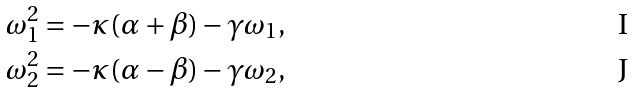Convert formula to latex. <formula><loc_0><loc_0><loc_500><loc_500>\omega _ { 1 } ^ { 2 } & = - \kappa ( \alpha + \beta ) - \gamma \omega _ { 1 } , \\ \omega _ { 2 } ^ { 2 } & = - \kappa ( \alpha - \beta ) - \gamma \omega _ { 2 } ,</formula> 